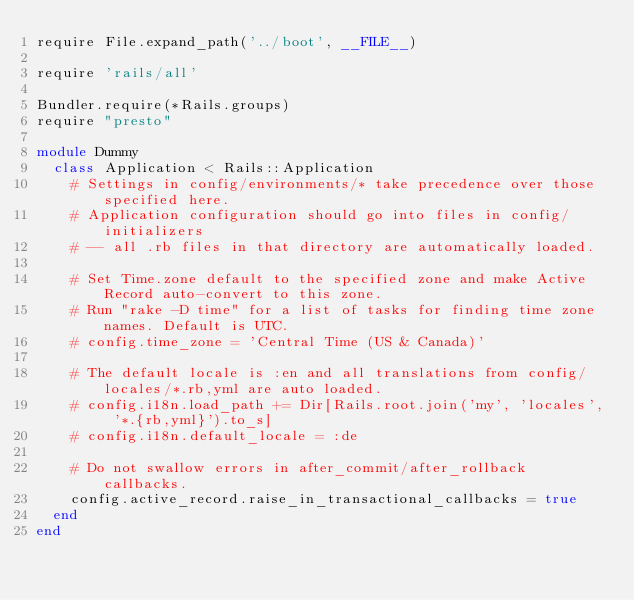<code> <loc_0><loc_0><loc_500><loc_500><_Ruby_>require File.expand_path('../boot', __FILE__)

require 'rails/all'

Bundler.require(*Rails.groups)
require "presto"

module Dummy
  class Application < Rails::Application
    # Settings in config/environments/* take precedence over those specified here.
    # Application configuration should go into files in config/initializers
    # -- all .rb files in that directory are automatically loaded.

    # Set Time.zone default to the specified zone and make Active Record auto-convert to this zone.
    # Run "rake -D time" for a list of tasks for finding time zone names. Default is UTC.
    # config.time_zone = 'Central Time (US & Canada)'

    # The default locale is :en and all translations from config/locales/*.rb,yml are auto loaded.
    # config.i18n.load_path += Dir[Rails.root.join('my', 'locales', '*.{rb,yml}').to_s]
    # config.i18n.default_locale = :de

    # Do not swallow errors in after_commit/after_rollback callbacks.
    config.active_record.raise_in_transactional_callbacks = true
  end
end

</code> 